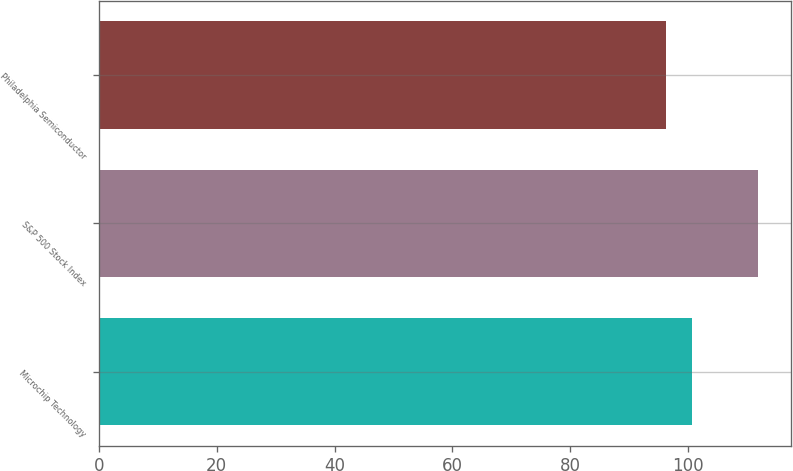Convert chart to OTSL. <chart><loc_0><loc_0><loc_500><loc_500><bar_chart><fcel>Microchip Technology<fcel>S&P 500 Stock Index<fcel>Philadelphia Semiconductor<nl><fcel>100.68<fcel>111.83<fcel>96.27<nl></chart> 